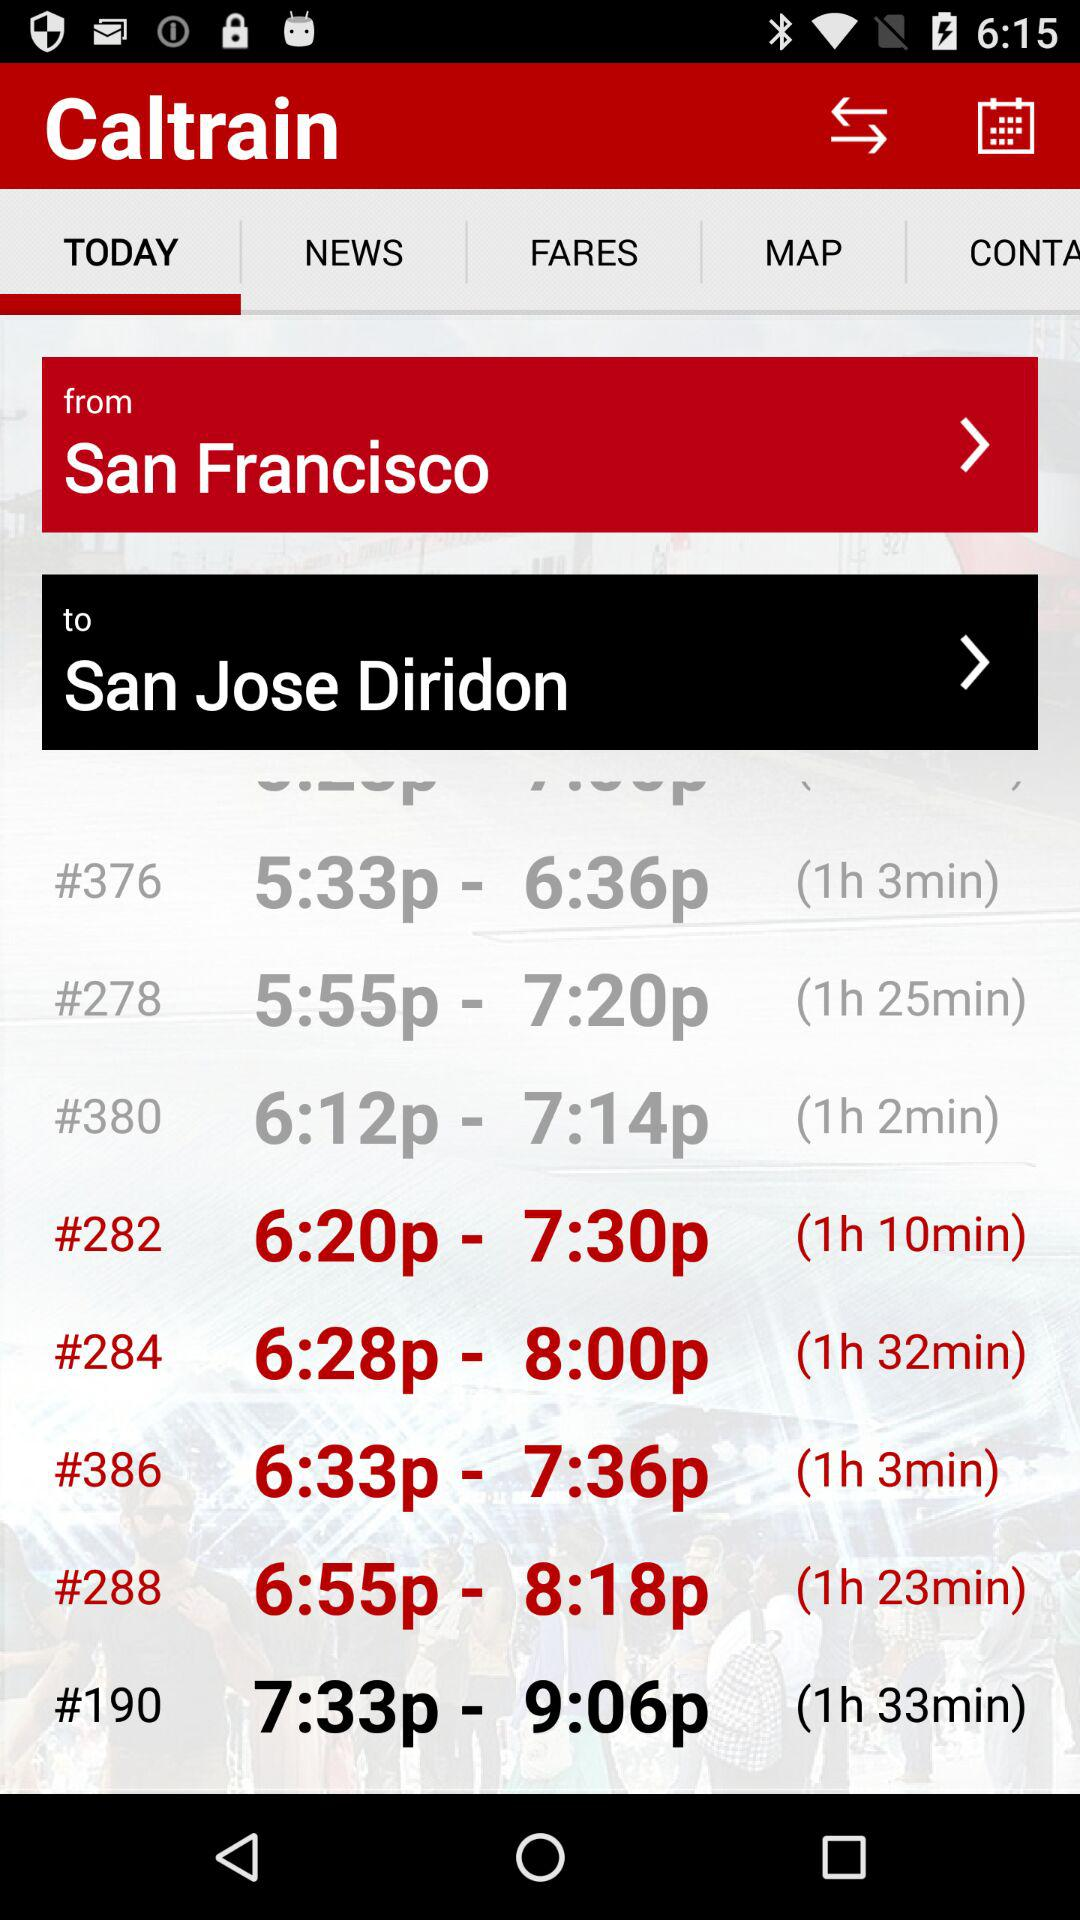What is the name of the application? The name of the application is "Caltrain". 